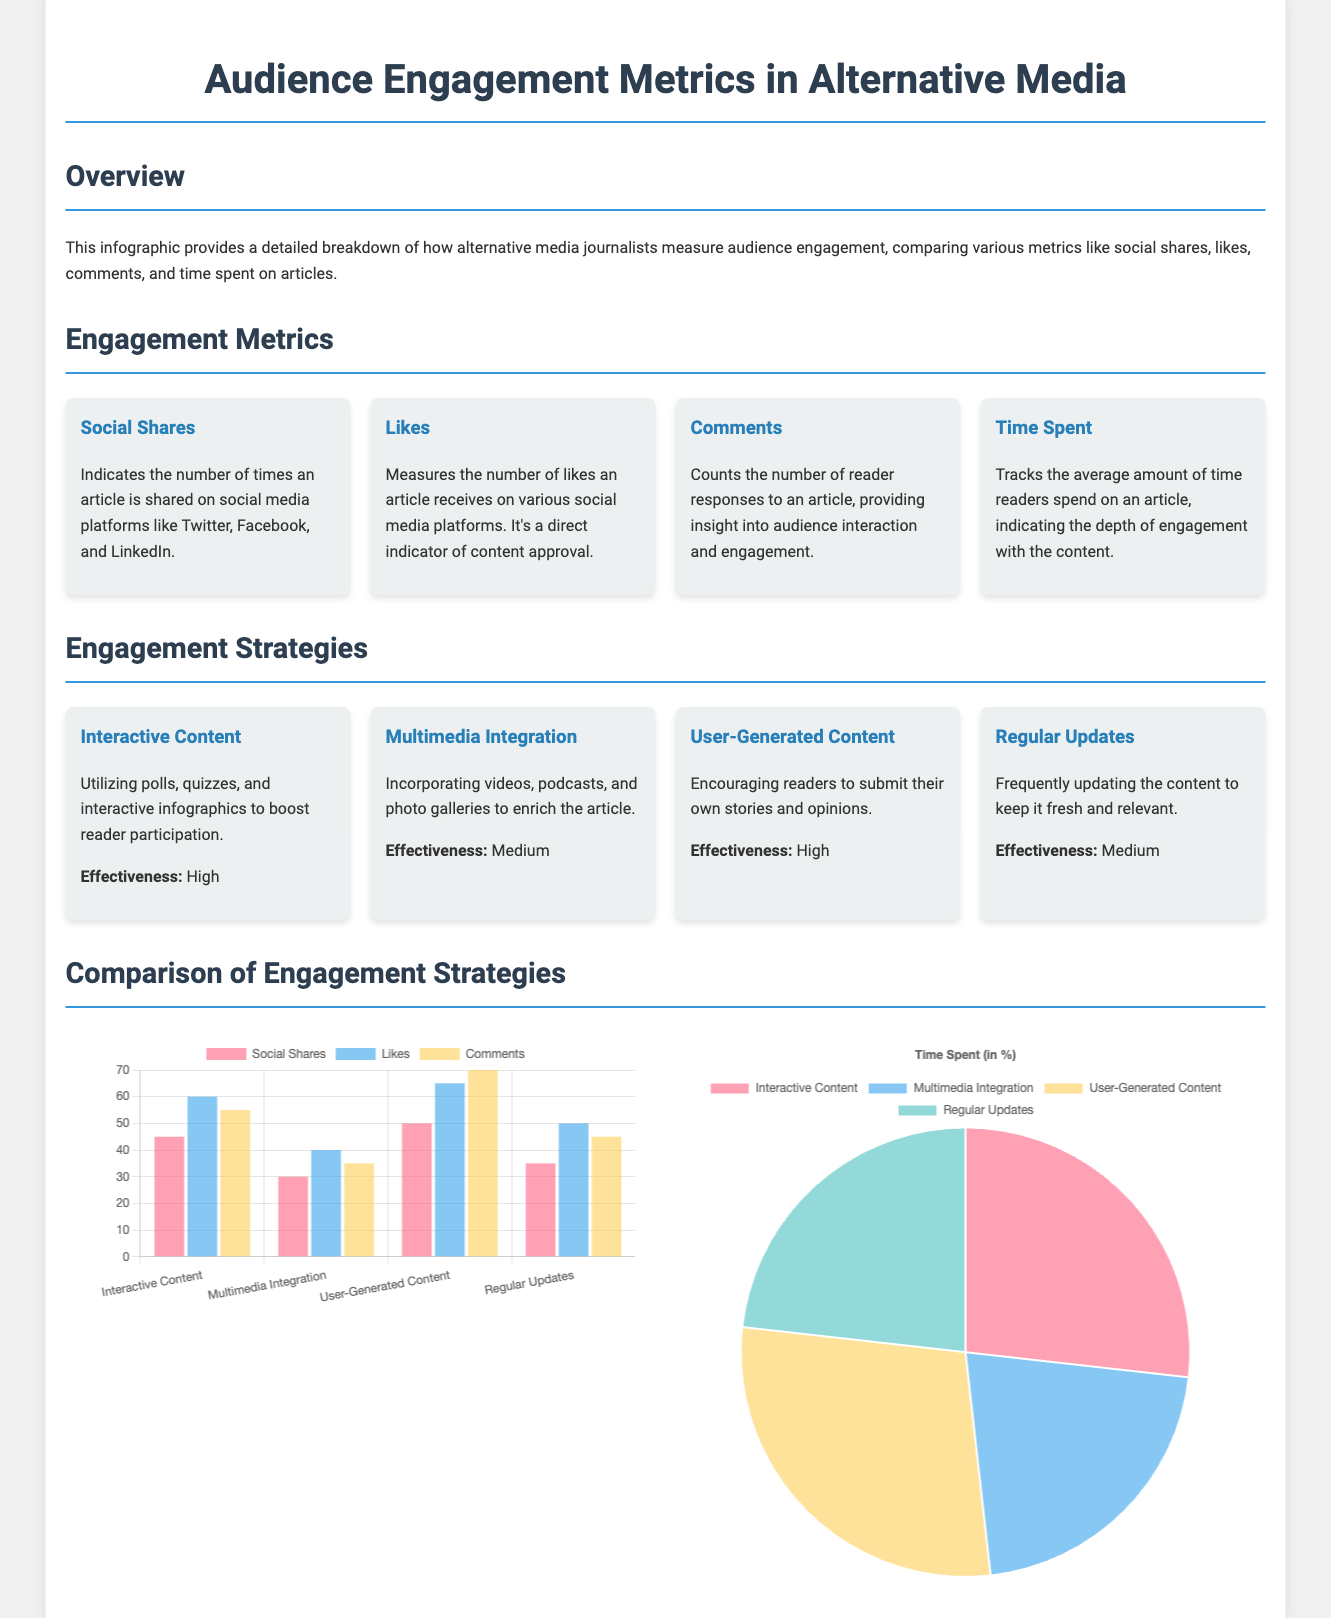What are the primary engagement metrics listed in the document? The document lists four primary engagement metrics: social shares, likes, comments, and time spent.
Answer: Social shares, likes, comments, time spent Which engagement strategy has the highest effectiveness rating? The highest effectiveness rating is associated with both interactive content and user-generated content, which both have a rating of high.
Answer: High How many total social shares does interactive content have according to the bar chart? The bar chart indicates that interactive content has 45 social shares.
Answer: 45 What percentage of time is spent on user-generated content according to the pie chart? The pie chart shows that user-generated content accounts for 80% of time spent.
Answer: 80% Which engagement metric measures direct audience interaction? Comments are the metric that directly measure audience interaction.
Answer: Comments What is the effectiveness rating for multimedia integration? The effectiveness rating for multimedia integration is medium.
Answer: Medium What is the average likes received by regular updates? Regular updates received an average of 50 likes according to the bar chart.
Answer: 50 Which graphic type is used to show the comparison of social shares, likes, and comments? A bar chart is used to show the comparison of social shares, likes, and comments.
Answer: Bar chart How are the different engagement strategies visually represented in the document? Engagement strategies are visually represented using cards for each strategy with effectiveness ratings.
Answer: Cards 